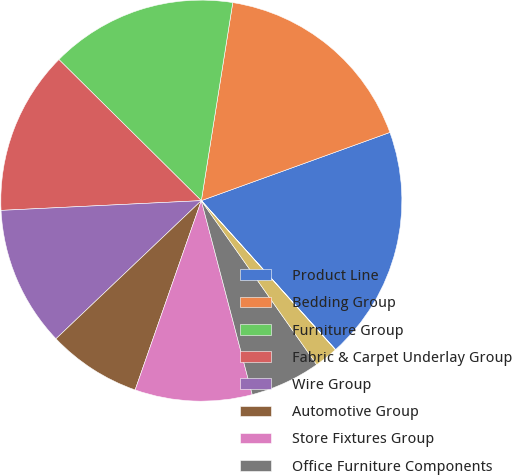Convert chart. <chart><loc_0><loc_0><loc_500><loc_500><pie_chart><fcel>Product Line<fcel>Bedding Group<fcel>Furniture Group<fcel>Fabric & Carpet Underlay Group<fcel>Wire Group<fcel>Automotive Group<fcel>Store Fixtures Group<fcel>Office Furniture Components<fcel>Commercial Vehicle Products<fcel>Tubing Group<nl><fcel>18.85%<fcel>16.97%<fcel>15.08%<fcel>13.2%<fcel>11.32%<fcel>7.55%<fcel>9.44%<fcel>5.67%<fcel>1.9%<fcel>0.02%<nl></chart> 